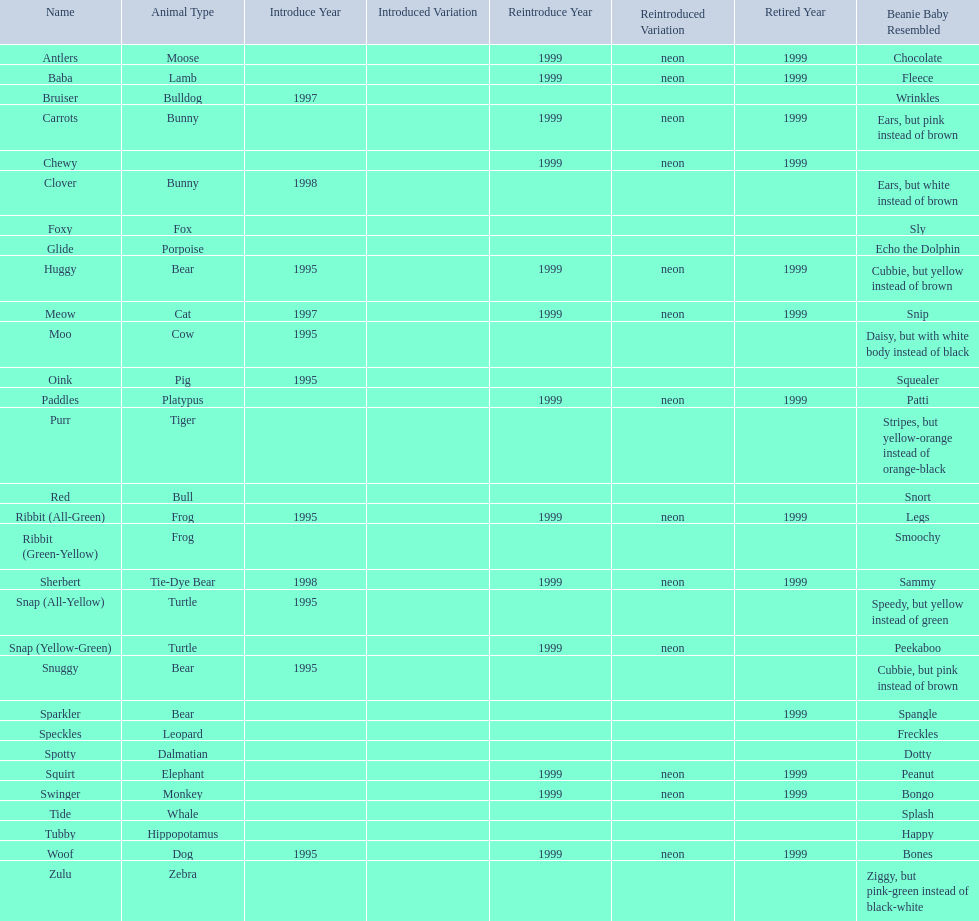What are the names listed? Antlers, Baba, Bruiser, Carrots, Chewy, Clover, Foxy, Glide, Huggy, Meow, Moo, Oink, Paddles, Purr, Red, Ribbit (All-Green), Ribbit (Green-Yellow), Sherbert, Snap (All-Yellow), Snap (Yellow-Green), Snuggy, Sparkler, Speckles, Spotty, Squirt, Swinger, Tide, Tubby, Woof, Zulu. Of these, which is the only pet without an animal type listed? Chewy. 